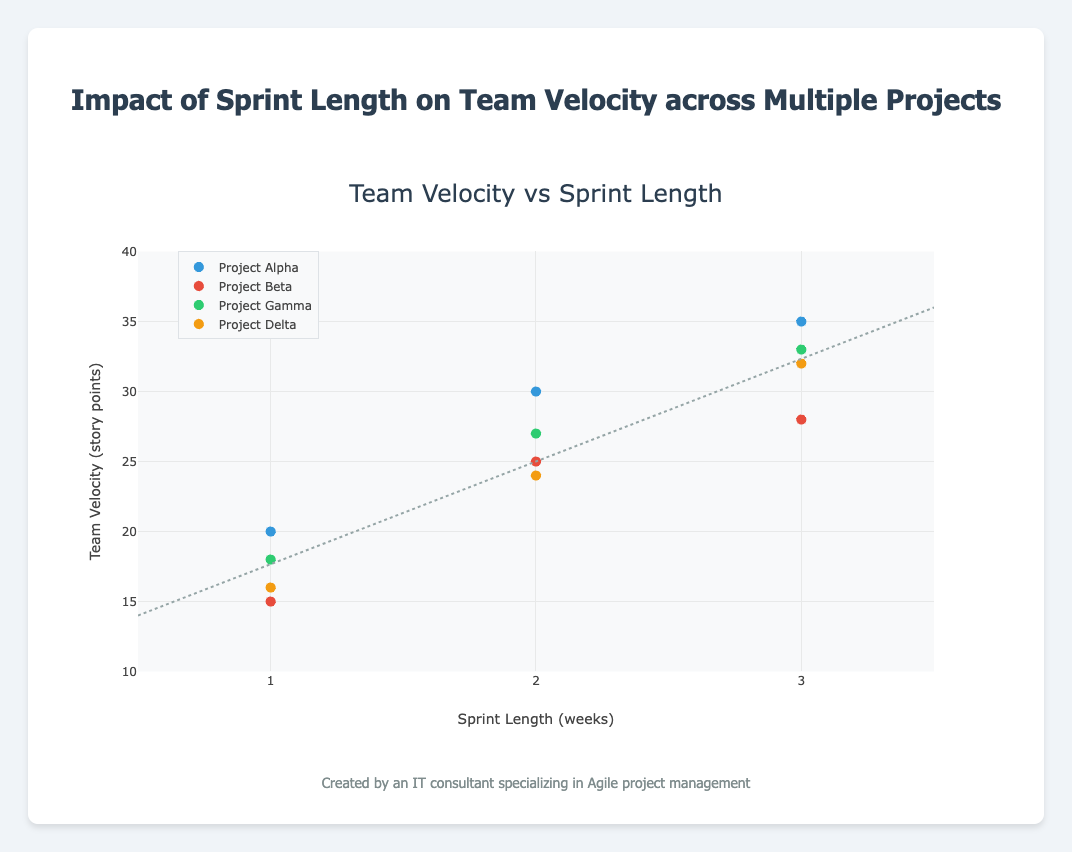What is the relationship represented by the title of the figure? The title of the figure states "Impact of Sprint Length on Team Velocity across Multiple Projects," which indicates that the chart shows how different sprint lengths affect the team's velocity in story points across several projects.
Answer: The impact of sprint length on team velocity What's the range of the x-axis in the figure? The x-axis represents the Sprint Length in weeks, ranging from 0.5 to 3.5 weeks, as indicated by the axis labels.
Answer: 0.5 to 3.5 weeks How many unique projects are represented in the scatter plot? The legend shows that there are four unique projects represented: Project Alpha, Project Beta, Project Gamma, and Project Delta.
Answer: Four Which project has the highest team velocity for a 3-week sprint length? By observing the data points on the scatter plot, Project Alpha has the highest team velocity at 3 weeks with 35 story points.
Answer: Project Alpha What is the trend line's approximate range on the y-axis? The trend line range on the y-axis is approximately from 14 to 36 story points.
Answer: 14 to 36 story points Compare the team velocity of Project Beta and Project Gamma for a 2-week sprint length. For a 2-week sprint length, Project Beta's team velocity is 25 story points, and Project Gamma's team velocity is 27 story points. By comparing these values, we see that Project Gamma has a higher team velocity.
Answer: Project Gamma Does every project follow the trend line closely? By examining how the data points of each project align with the trend line, we observe slight deviations, indicating not all projects follow the trend line closely.
Answer: No What is the average team velocity for a 3-week sprint length across all projects? The team velocities for the 3-week sprint length are 35, 28, 33, and 32 for Projects Alpha, Beta, Gamma, and Delta respectively. Average = (35 + 28 + 33 + 32) / 4 = 32
Answer: 32 Which project shows the most significant increase in team velocity when moving from a 1-week to a 3-week sprint length? By observing the increments, Project Alpha increases from 20 to 35 (15 points), Project Beta from 15 to 28 (13 points), Project Gamma from 18 to 33 (15 points), and Project Delta from 16 to 32 (16 points). Project Delta has the most significant increase.
Answer: Project Delta 